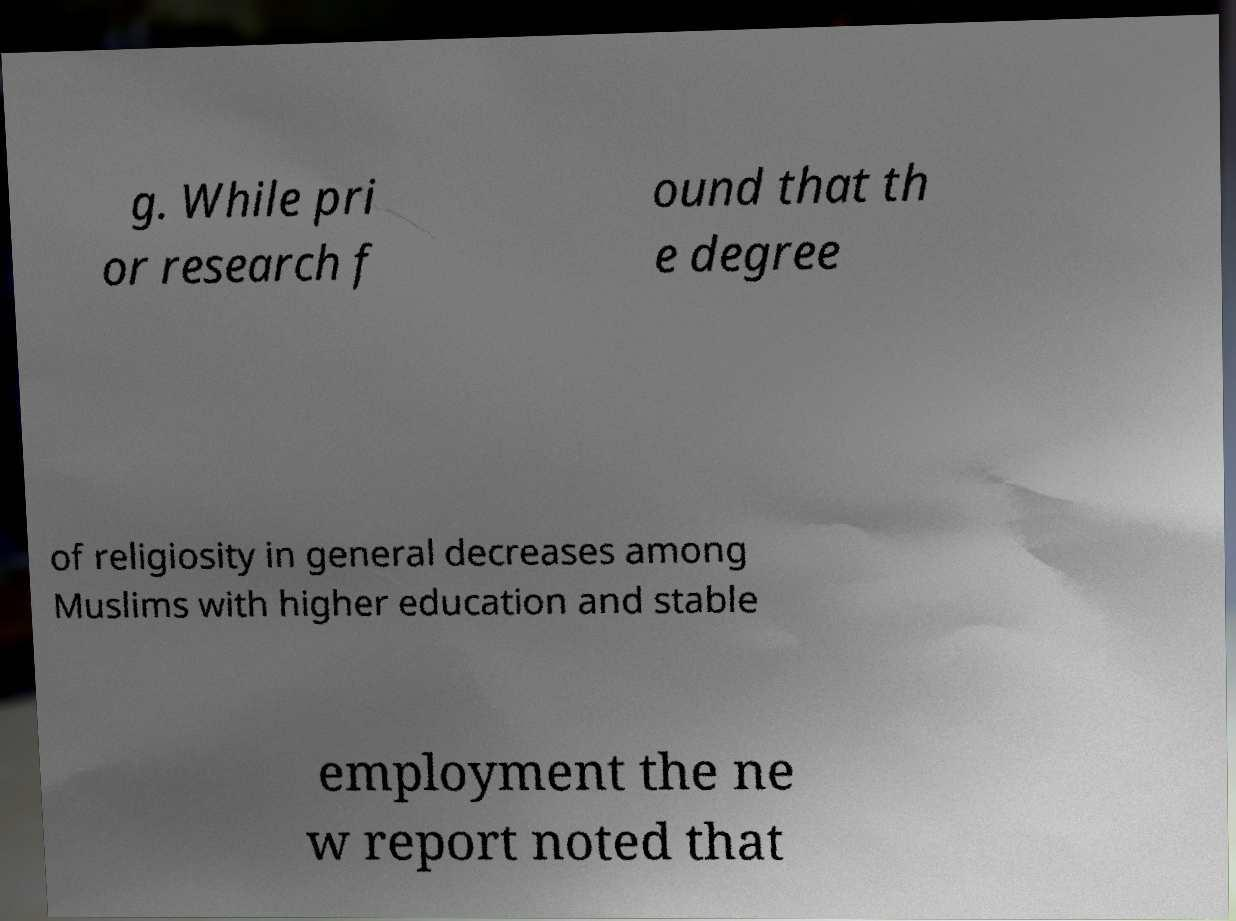There's text embedded in this image that I need extracted. Can you transcribe it verbatim? g. While pri or research f ound that th e degree of religiosity in general decreases among Muslims with higher education and stable employment the ne w report noted that 